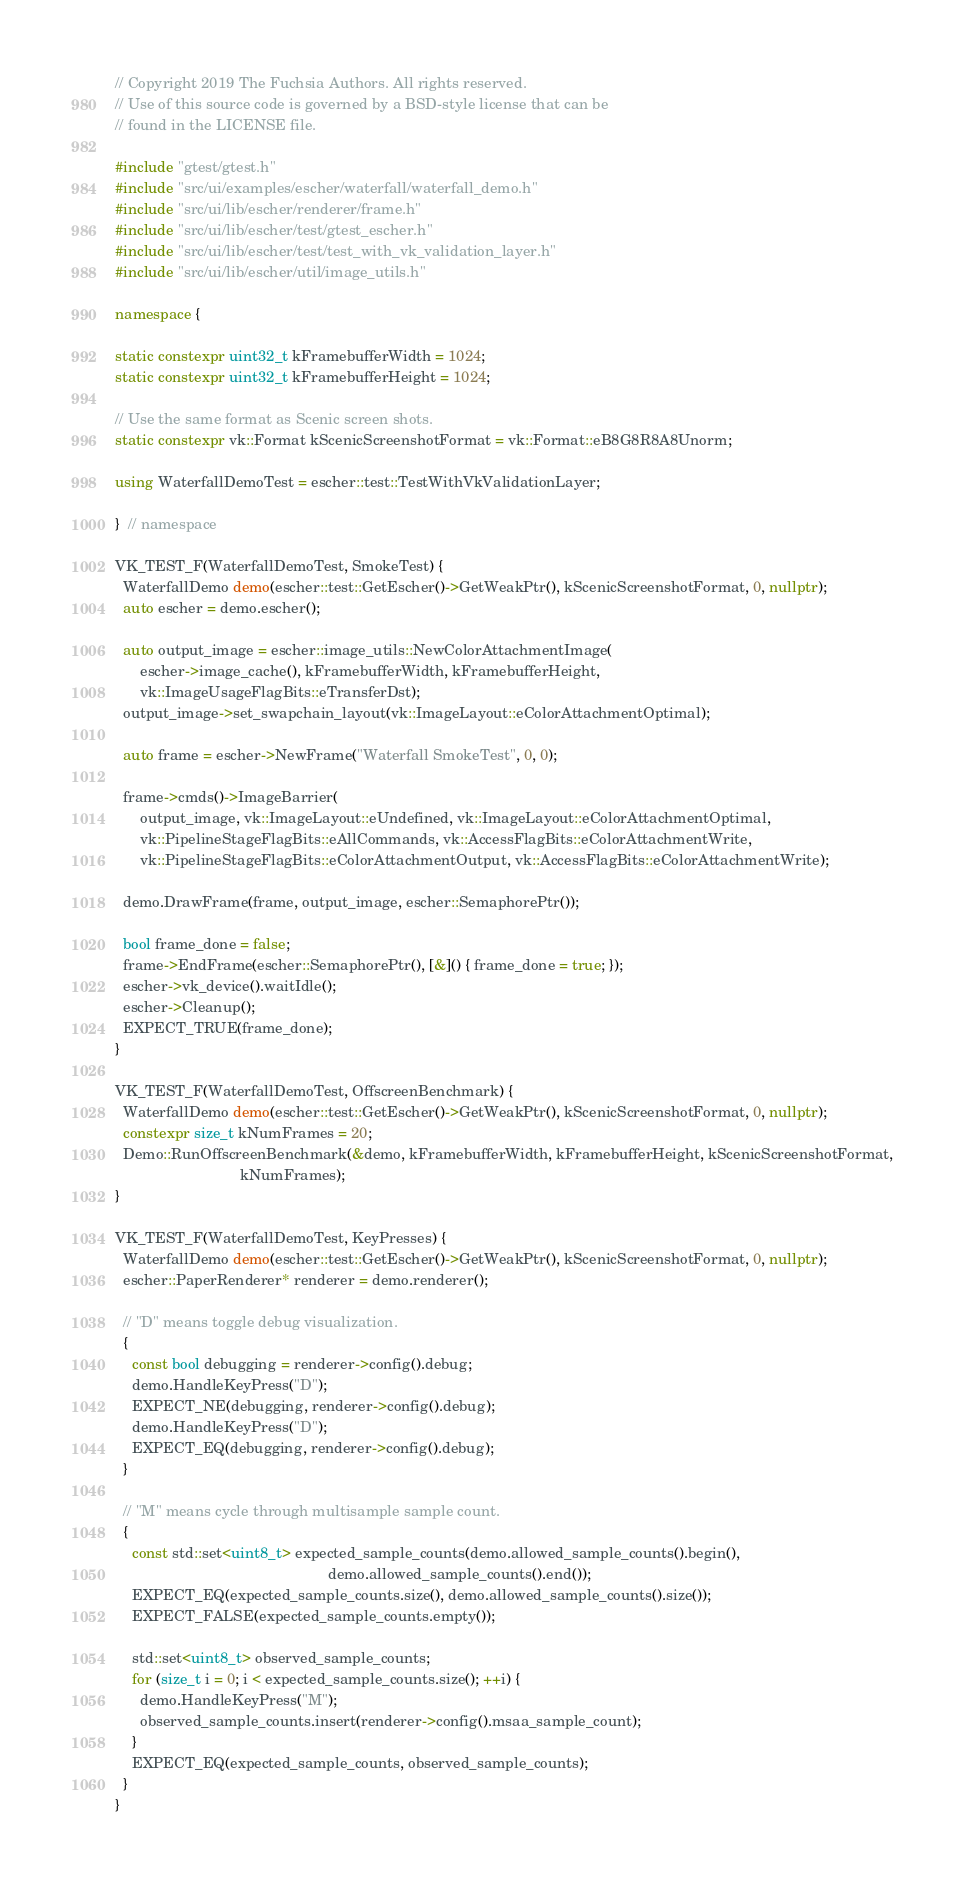<code> <loc_0><loc_0><loc_500><loc_500><_C++_>// Copyright 2019 The Fuchsia Authors. All rights reserved.
// Use of this source code is governed by a BSD-style license that can be
// found in the LICENSE file.

#include "gtest/gtest.h"
#include "src/ui/examples/escher/waterfall/waterfall_demo.h"
#include "src/ui/lib/escher/renderer/frame.h"
#include "src/ui/lib/escher/test/gtest_escher.h"
#include "src/ui/lib/escher/test/test_with_vk_validation_layer.h"
#include "src/ui/lib/escher/util/image_utils.h"

namespace {

static constexpr uint32_t kFramebufferWidth = 1024;
static constexpr uint32_t kFramebufferHeight = 1024;

// Use the same format as Scenic screen shots.
static constexpr vk::Format kScenicScreenshotFormat = vk::Format::eB8G8R8A8Unorm;

using WaterfallDemoTest = escher::test::TestWithVkValidationLayer;

}  // namespace

VK_TEST_F(WaterfallDemoTest, SmokeTest) {
  WaterfallDemo demo(escher::test::GetEscher()->GetWeakPtr(), kScenicScreenshotFormat, 0, nullptr);
  auto escher = demo.escher();

  auto output_image = escher::image_utils::NewColorAttachmentImage(
      escher->image_cache(), kFramebufferWidth, kFramebufferHeight,
      vk::ImageUsageFlagBits::eTransferDst);
  output_image->set_swapchain_layout(vk::ImageLayout::eColorAttachmentOptimal);

  auto frame = escher->NewFrame("Waterfall SmokeTest", 0, 0);

  frame->cmds()->ImageBarrier(
      output_image, vk::ImageLayout::eUndefined, vk::ImageLayout::eColorAttachmentOptimal,
      vk::PipelineStageFlagBits::eAllCommands, vk::AccessFlagBits::eColorAttachmentWrite,
      vk::PipelineStageFlagBits::eColorAttachmentOutput, vk::AccessFlagBits::eColorAttachmentWrite);

  demo.DrawFrame(frame, output_image, escher::SemaphorePtr());

  bool frame_done = false;
  frame->EndFrame(escher::SemaphorePtr(), [&]() { frame_done = true; });
  escher->vk_device().waitIdle();
  escher->Cleanup();
  EXPECT_TRUE(frame_done);
}

VK_TEST_F(WaterfallDemoTest, OffscreenBenchmark) {
  WaterfallDemo demo(escher::test::GetEscher()->GetWeakPtr(), kScenicScreenshotFormat, 0, nullptr);
  constexpr size_t kNumFrames = 20;
  Demo::RunOffscreenBenchmark(&demo, kFramebufferWidth, kFramebufferHeight, kScenicScreenshotFormat,
                              kNumFrames);
}

VK_TEST_F(WaterfallDemoTest, KeyPresses) {
  WaterfallDemo demo(escher::test::GetEscher()->GetWeakPtr(), kScenicScreenshotFormat, 0, nullptr);
  escher::PaperRenderer* renderer = demo.renderer();

  // "D" means toggle debug visualization.
  {
    const bool debugging = renderer->config().debug;
    demo.HandleKeyPress("D");
    EXPECT_NE(debugging, renderer->config().debug);
    demo.HandleKeyPress("D");
    EXPECT_EQ(debugging, renderer->config().debug);
  }

  // "M" means cycle through multisample sample count.
  {
    const std::set<uint8_t> expected_sample_counts(demo.allowed_sample_counts().begin(),
                                                   demo.allowed_sample_counts().end());
    EXPECT_EQ(expected_sample_counts.size(), demo.allowed_sample_counts().size());
    EXPECT_FALSE(expected_sample_counts.empty());

    std::set<uint8_t> observed_sample_counts;
    for (size_t i = 0; i < expected_sample_counts.size(); ++i) {
      demo.HandleKeyPress("M");
      observed_sample_counts.insert(renderer->config().msaa_sample_count);
    }
    EXPECT_EQ(expected_sample_counts, observed_sample_counts);
  }
}
</code> 